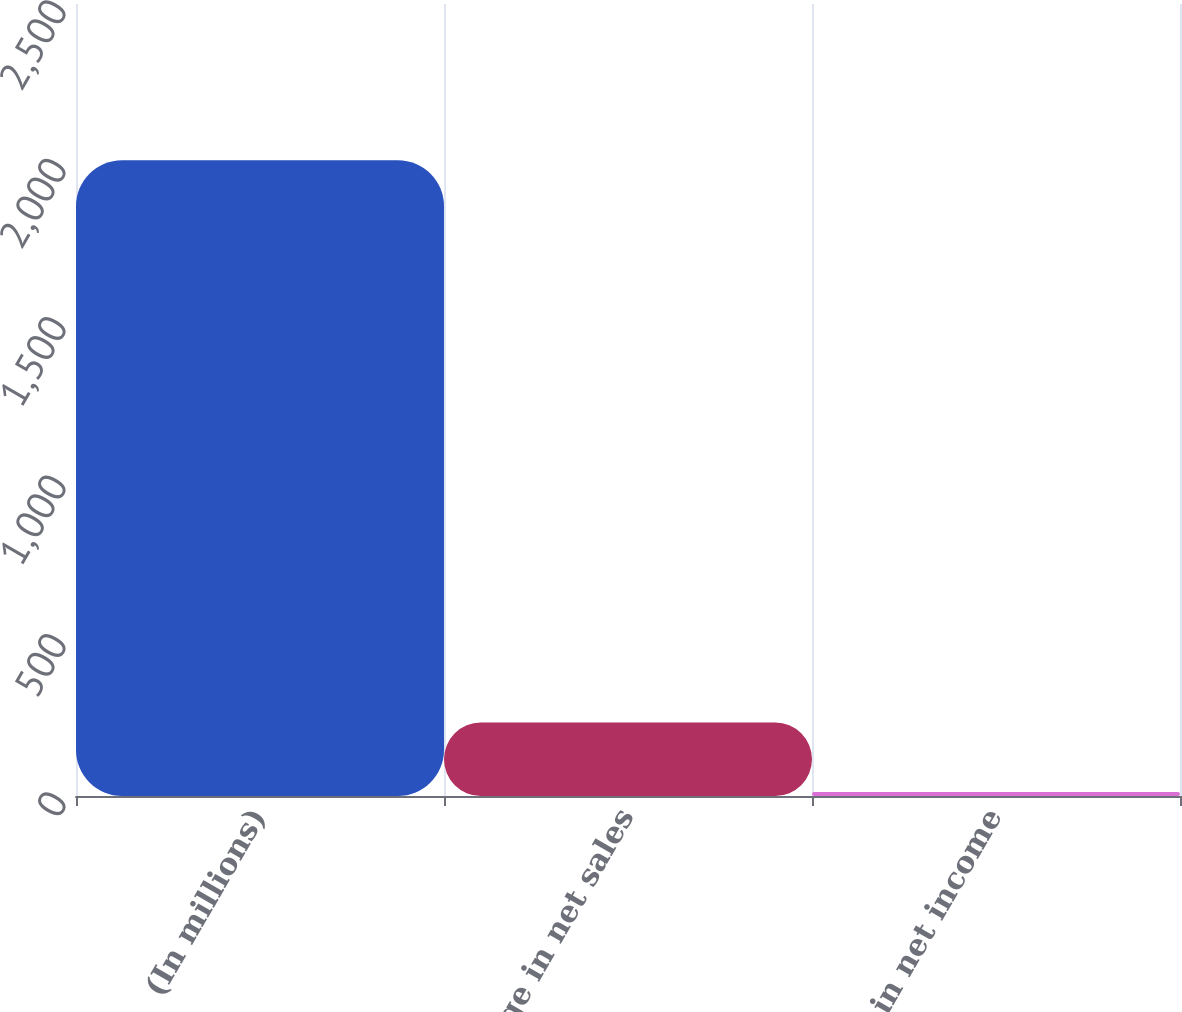<chart> <loc_0><loc_0><loc_500><loc_500><bar_chart><fcel>(In millions)<fcel>Change in net sales<fcel>Change in net income<nl><fcel>2007<fcel>232<fcel>13<nl></chart> 